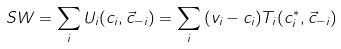Convert formula to latex. <formula><loc_0><loc_0><loc_500><loc_500>S W = \sum _ { i } { U _ { i } ( c _ { i } , \vec { c } _ { - i } ) } = \sum _ { i } { ( v _ { i } - c _ { i } ) T _ { i } ( c ^ { * } _ { i } , \vec { c } _ { - i } ) }</formula> 